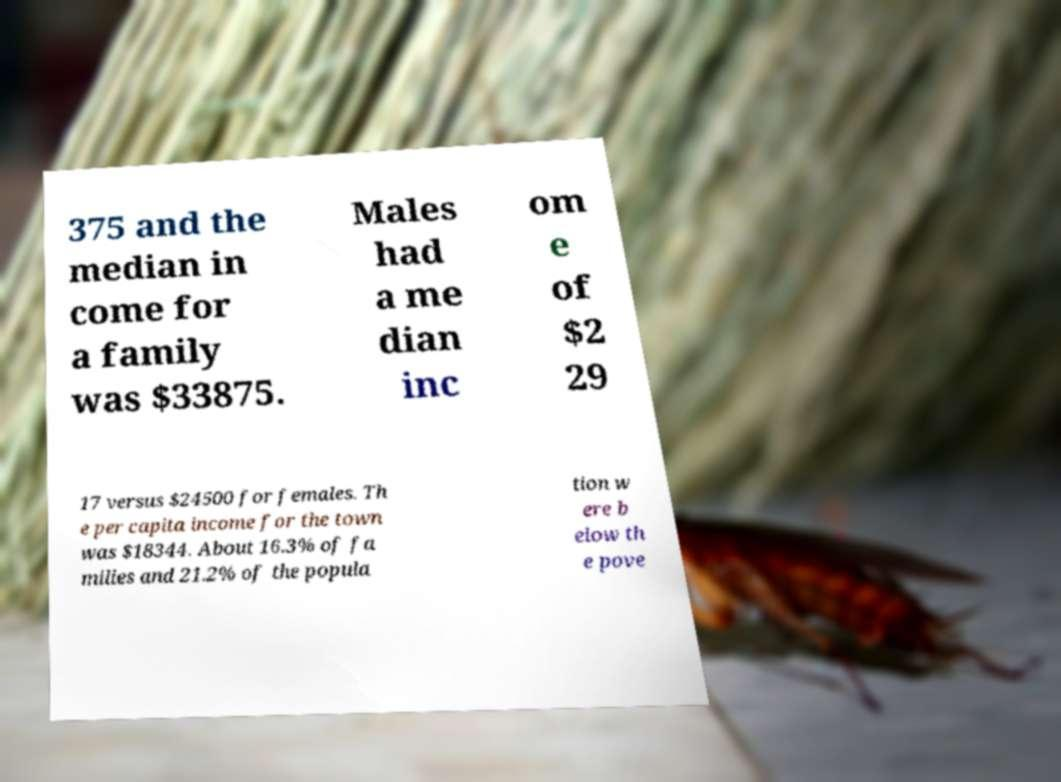Please read and relay the text visible in this image. What does it say? 375 and the median in come for a family was $33875. Males had a me dian inc om e of $2 29 17 versus $24500 for females. Th e per capita income for the town was $18344. About 16.3% of fa milies and 21.2% of the popula tion w ere b elow th e pove 